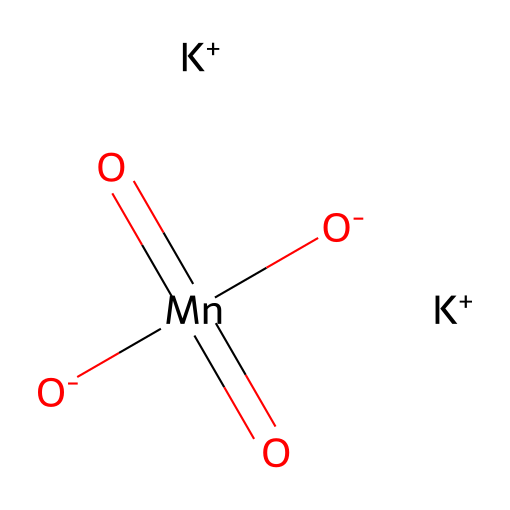What is the molecular formula of this compound? The SMILES notation breaks down to identify each element present. By counting the elements depicted, we find there are 2 potassium (K), 1 manganese (Mn), and 4 oxygen (O) atoms. Hence, the molecular formula is K2MnO4.
Answer: K2MnO4 How many oxygen atoms are present in this chemical? The structural representation indicates there are four oxygen atoms visually connected to manganese, which confirms the count from the molecular formula.
Answer: 4 What is the oxidation state of manganese in this compound? In potassium permanganate, manganese is centrally located and is typically found in a +7 oxidation state when bonded to four oxygen atoms, which can be inferred through its common oxidation states and confirming through the overall charge balance in the compound.
Answer: +7 What is the total number of atoms in this molecule? Adding all the atoms together: 2 potassium atoms, 1 manganese atom, and 4 oxygen atoms results in 2 + 1 + 4 = 7 atoms total.
Answer: 7 Is potassium permanganate an oxidizer? Potassium permanganate contains manganese in a high oxidation state and readily accepts electrons from other substances, confirming its classification as a strong oxidizing agent.
Answer: Yes How many potassium ions are present in this chemical? Direct observation of the SMILES notation shows two separate instances of K+, indicating two potassium ions are present in the structure.
Answer: 2 